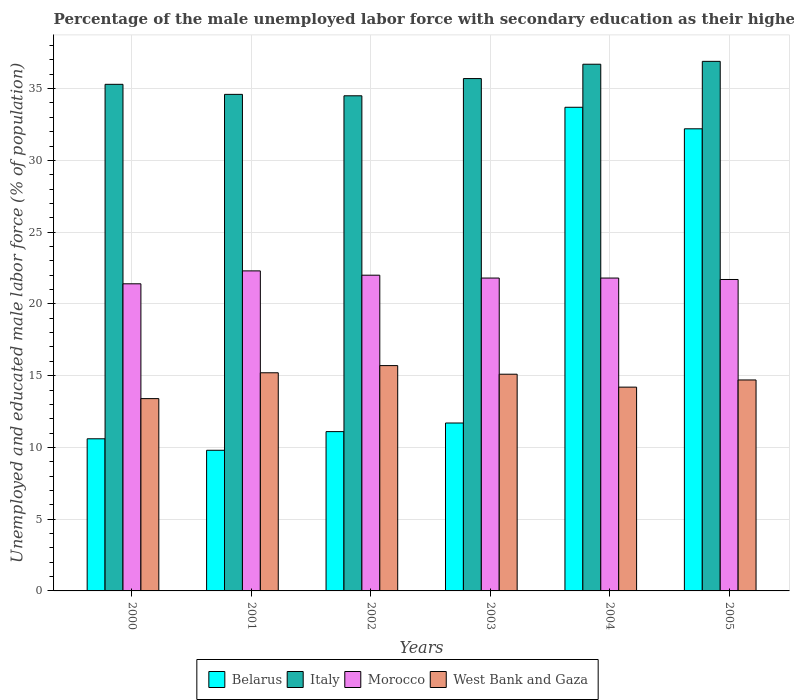How many groups of bars are there?
Offer a very short reply. 6. Are the number of bars on each tick of the X-axis equal?
Provide a short and direct response. Yes. What is the label of the 4th group of bars from the left?
Keep it short and to the point. 2003. What is the percentage of the unemployed male labor force with secondary education in West Bank and Gaza in 2001?
Offer a terse response. 15.2. Across all years, what is the maximum percentage of the unemployed male labor force with secondary education in West Bank and Gaza?
Make the answer very short. 15.7. Across all years, what is the minimum percentage of the unemployed male labor force with secondary education in Belarus?
Keep it short and to the point. 9.8. In which year was the percentage of the unemployed male labor force with secondary education in West Bank and Gaza maximum?
Your answer should be compact. 2002. In which year was the percentage of the unemployed male labor force with secondary education in Morocco minimum?
Your response must be concise. 2000. What is the total percentage of the unemployed male labor force with secondary education in Italy in the graph?
Your answer should be very brief. 213.7. What is the difference between the percentage of the unemployed male labor force with secondary education in West Bank and Gaza in 2001 and that in 2004?
Provide a succinct answer. 1. What is the difference between the percentage of the unemployed male labor force with secondary education in Morocco in 2003 and the percentage of the unemployed male labor force with secondary education in Belarus in 2002?
Offer a very short reply. 10.7. What is the average percentage of the unemployed male labor force with secondary education in Morocco per year?
Offer a terse response. 21.83. In the year 2001, what is the difference between the percentage of the unemployed male labor force with secondary education in West Bank and Gaza and percentage of the unemployed male labor force with secondary education in Italy?
Your response must be concise. -19.4. In how many years, is the percentage of the unemployed male labor force with secondary education in Morocco greater than 19 %?
Offer a terse response. 6. What is the ratio of the percentage of the unemployed male labor force with secondary education in Belarus in 2002 to that in 2003?
Make the answer very short. 0.95. Is the percentage of the unemployed male labor force with secondary education in Morocco in 2000 less than that in 2005?
Keep it short and to the point. Yes. Is the difference between the percentage of the unemployed male labor force with secondary education in West Bank and Gaza in 2001 and 2004 greater than the difference between the percentage of the unemployed male labor force with secondary education in Italy in 2001 and 2004?
Your answer should be very brief. Yes. What is the difference between the highest and the second highest percentage of the unemployed male labor force with secondary education in West Bank and Gaza?
Provide a succinct answer. 0.5. What is the difference between the highest and the lowest percentage of the unemployed male labor force with secondary education in West Bank and Gaza?
Your answer should be compact. 2.3. In how many years, is the percentage of the unemployed male labor force with secondary education in Morocco greater than the average percentage of the unemployed male labor force with secondary education in Morocco taken over all years?
Your answer should be very brief. 2. Is the sum of the percentage of the unemployed male labor force with secondary education in West Bank and Gaza in 2003 and 2004 greater than the maximum percentage of the unemployed male labor force with secondary education in Morocco across all years?
Keep it short and to the point. Yes. What does the 3rd bar from the left in 2000 represents?
Keep it short and to the point. Morocco. What does the 4th bar from the right in 2005 represents?
Offer a terse response. Belarus. Is it the case that in every year, the sum of the percentage of the unemployed male labor force with secondary education in Morocco and percentage of the unemployed male labor force with secondary education in Belarus is greater than the percentage of the unemployed male labor force with secondary education in Italy?
Provide a succinct answer. No. Are all the bars in the graph horizontal?
Ensure brevity in your answer.  No. What is the difference between two consecutive major ticks on the Y-axis?
Your answer should be very brief. 5. Does the graph contain any zero values?
Give a very brief answer. No. How many legend labels are there?
Provide a short and direct response. 4. What is the title of the graph?
Keep it short and to the point. Percentage of the male unemployed labor force with secondary education as their highest grade. Does "Cambodia" appear as one of the legend labels in the graph?
Give a very brief answer. No. What is the label or title of the Y-axis?
Provide a succinct answer. Unemployed and educated male labor force (% of population). What is the Unemployed and educated male labor force (% of population) of Belarus in 2000?
Provide a succinct answer. 10.6. What is the Unemployed and educated male labor force (% of population) of Italy in 2000?
Offer a very short reply. 35.3. What is the Unemployed and educated male labor force (% of population) of Morocco in 2000?
Ensure brevity in your answer.  21.4. What is the Unemployed and educated male labor force (% of population) in West Bank and Gaza in 2000?
Give a very brief answer. 13.4. What is the Unemployed and educated male labor force (% of population) of Belarus in 2001?
Your answer should be very brief. 9.8. What is the Unemployed and educated male labor force (% of population) in Italy in 2001?
Provide a short and direct response. 34.6. What is the Unemployed and educated male labor force (% of population) of Morocco in 2001?
Your answer should be very brief. 22.3. What is the Unemployed and educated male labor force (% of population) of West Bank and Gaza in 2001?
Your response must be concise. 15.2. What is the Unemployed and educated male labor force (% of population) of Belarus in 2002?
Make the answer very short. 11.1. What is the Unemployed and educated male labor force (% of population) in Italy in 2002?
Make the answer very short. 34.5. What is the Unemployed and educated male labor force (% of population) in West Bank and Gaza in 2002?
Provide a short and direct response. 15.7. What is the Unemployed and educated male labor force (% of population) in Belarus in 2003?
Provide a succinct answer. 11.7. What is the Unemployed and educated male labor force (% of population) of Italy in 2003?
Make the answer very short. 35.7. What is the Unemployed and educated male labor force (% of population) of Morocco in 2003?
Provide a succinct answer. 21.8. What is the Unemployed and educated male labor force (% of population) in West Bank and Gaza in 2003?
Ensure brevity in your answer.  15.1. What is the Unemployed and educated male labor force (% of population) in Belarus in 2004?
Offer a very short reply. 33.7. What is the Unemployed and educated male labor force (% of population) in Italy in 2004?
Offer a very short reply. 36.7. What is the Unemployed and educated male labor force (% of population) of Morocco in 2004?
Offer a terse response. 21.8. What is the Unemployed and educated male labor force (% of population) in West Bank and Gaza in 2004?
Your answer should be compact. 14.2. What is the Unemployed and educated male labor force (% of population) in Belarus in 2005?
Keep it short and to the point. 32.2. What is the Unemployed and educated male labor force (% of population) of Italy in 2005?
Provide a short and direct response. 36.9. What is the Unemployed and educated male labor force (% of population) of Morocco in 2005?
Offer a terse response. 21.7. What is the Unemployed and educated male labor force (% of population) in West Bank and Gaza in 2005?
Offer a very short reply. 14.7. Across all years, what is the maximum Unemployed and educated male labor force (% of population) of Belarus?
Provide a short and direct response. 33.7. Across all years, what is the maximum Unemployed and educated male labor force (% of population) in Italy?
Provide a succinct answer. 36.9. Across all years, what is the maximum Unemployed and educated male labor force (% of population) in Morocco?
Keep it short and to the point. 22.3. Across all years, what is the maximum Unemployed and educated male labor force (% of population) of West Bank and Gaza?
Your response must be concise. 15.7. Across all years, what is the minimum Unemployed and educated male labor force (% of population) of Belarus?
Offer a very short reply. 9.8. Across all years, what is the minimum Unemployed and educated male labor force (% of population) in Italy?
Give a very brief answer. 34.5. Across all years, what is the minimum Unemployed and educated male labor force (% of population) of Morocco?
Provide a short and direct response. 21.4. Across all years, what is the minimum Unemployed and educated male labor force (% of population) of West Bank and Gaza?
Provide a short and direct response. 13.4. What is the total Unemployed and educated male labor force (% of population) of Belarus in the graph?
Your answer should be very brief. 109.1. What is the total Unemployed and educated male labor force (% of population) in Italy in the graph?
Your answer should be compact. 213.7. What is the total Unemployed and educated male labor force (% of population) in Morocco in the graph?
Offer a terse response. 131. What is the total Unemployed and educated male labor force (% of population) in West Bank and Gaza in the graph?
Make the answer very short. 88.3. What is the difference between the Unemployed and educated male labor force (% of population) of Morocco in 2000 and that in 2001?
Ensure brevity in your answer.  -0.9. What is the difference between the Unemployed and educated male labor force (% of population) in West Bank and Gaza in 2000 and that in 2002?
Offer a terse response. -2.3. What is the difference between the Unemployed and educated male labor force (% of population) in West Bank and Gaza in 2000 and that in 2003?
Keep it short and to the point. -1.7. What is the difference between the Unemployed and educated male labor force (% of population) of Belarus in 2000 and that in 2004?
Offer a terse response. -23.1. What is the difference between the Unemployed and educated male labor force (% of population) in Morocco in 2000 and that in 2004?
Provide a short and direct response. -0.4. What is the difference between the Unemployed and educated male labor force (% of population) of Belarus in 2000 and that in 2005?
Offer a terse response. -21.6. What is the difference between the Unemployed and educated male labor force (% of population) in Italy in 2000 and that in 2005?
Give a very brief answer. -1.6. What is the difference between the Unemployed and educated male labor force (% of population) in Italy in 2001 and that in 2002?
Your answer should be compact. 0.1. What is the difference between the Unemployed and educated male labor force (% of population) in Morocco in 2001 and that in 2002?
Your answer should be compact. 0.3. What is the difference between the Unemployed and educated male labor force (% of population) in Belarus in 2001 and that in 2003?
Your answer should be compact. -1.9. What is the difference between the Unemployed and educated male labor force (% of population) of Morocco in 2001 and that in 2003?
Your answer should be very brief. 0.5. What is the difference between the Unemployed and educated male labor force (% of population) in West Bank and Gaza in 2001 and that in 2003?
Offer a terse response. 0.1. What is the difference between the Unemployed and educated male labor force (% of population) in Belarus in 2001 and that in 2004?
Your answer should be very brief. -23.9. What is the difference between the Unemployed and educated male labor force (% of population) in Italy in 2001 and that in 2004?
Your response must be concise. -2.1. What is the difference between the Unemployed and educated male labor force (% of population) in Morocco in 2001 and that in 2004?
Give a very brief answer. 0.5. What is the difference between the Unemployed and educated male labor force (% of population) of West Bank and Gaza in 2001 and that in 2004?
Offer a very short reply. 1. What is the difference between the Unemployed and educated male labor force (% of population) in Belarus in 2001 and that in 2005?
Your response must be concise. -22.4. What is the difference between the Unemployed and educated male labor force (% of population) of Italy in 2001 and that in 2005?
Give a very brief answer. -2.3. What is the difference between the Unemployed and educated male labor force (% of population) of Morocco in 2001 and that in 2005?
Keep it short and to the point. 0.6. What is the difference between the Unemployed and educated male labor force (% of population) of West Bank and Gaza in 2001 and that in 2005?
Keep it short and to the point. 0.5. What is the difference between the Unemployed and educated male labor force (% of population) in Morocco in 2002 and that in 2003?
Ensure brevity in your answer.  0.2. What is the difference between the Unemployed and educated male labor force (% of population) of Belarus in 2002 and that in 2004?
Provide a short and direct response. -22.6. What is the difference between the Unemployed and educated male labor force (% of population) in Italy in 2002 and that in 2004?
Provide a short and direct response. -2.2. What is the difference between the Unemployed and educated male labor force (% of population) of Morocco in 2002 and that in 2004?
Keep it short and to the point. 0.2. What is the difference between the Unemployed and educated male labor force (% of population) of West Bank and Gaza in 2002 and that in 2004?
Provide a succinct answer. 1.5. What is the difference between the Unemployed and educated male labor force (% of population) of Belarus in 2002 and that in 2005?
Offer a very short reply. -21.1. What is the difference between the Unemployed and educated male labor force (% of population) in Italy in 2002 and that in 2005?
Your answer should be very brief. -2.4. What is the difference between the Unemployed and educated male labor force (% of population) of Morocco in 2002 and that in 2005?
Make the answer very short. 0.3. What is the difference between the Unemployed and educated male labor force (% of population) of Belarus in 2003 and that in 2004?
Your response must be concise. -22. What is the difference between the Unemployed and educated male labor force (% of population) of Italy in 2003 and that in 2004?
Make the answer very short. -1. What is the difference between the Unemployed and educated male labor force (% of population) of Belarus in 2003 and that in 2005?
Give a very brief answer. -20.5. What is the difference between the Unemployed and educated male labor force (% of population) in West Bank and Gaza in 2003 and that in 2005?
Make the answer very short. 0.4. What is the difference between the Unemployed and educated male labor force (% of population) of Belarus in 2004 and that in 2005?
Your response must be concise. 1.5. What is the difference between the Unemployed and educated male labor force (% of population) in Italy in 2004 and that in 2005?
Give a very brief answer. -0.2. What is the difference between the Unemployed and educated male labor force (% of population) of West Bank and Gaza in 2004 and that in 2005?
Your answer should be compact. -0.5. What is the difference between the Unemployed and educated male labor force (% of population) of Belarus in 2000 and the Unemployed and educated male labor force (% of population) of West Bank and Gaza in 2001?
Offer a terse response. -4.6. What is the difference between the Unemployed and educated male labor force (% of population) of Italy in 2000 and the Unemployed and educated male labor force (% of population) of Morocco in 2001?
Give a very brief answer. 13. What is the difference between the Unemployed and educated male labor force (% of population) of Italy in 2000 and the Unemployed and educated male labor force (% of population) of West Bank and Gaza in 2001?
Your answer should be compact. 20.1. What is the difference between the Unemployed and educated male labor force (% of population) in Belarus in 2000 and the Unemployed and educated male labor force (% of population) in Italy in 2002?
Your answer should be compact. -23.9. What is the difference between the Unemployed and educated male labor force (% of population) in Belarus in 2000 and the Unemployed and educated male labor force (% of population) in Morocco in 2002?
Your response must be concise. -11.4. What is the difference between the Unemployed and educated male labor force (% of population) of Belarus in 2000 and the Unemployed and educated male labor force (% of population) of West Bank and Gaza in 2002?
Ensure brevity in your answer.  -5.1. What is the difference between the Unemployed and educated male labor force (% of population) in Italy in 2000 and the Unemployed and educated male labor force (% of population) in Morocco in 2002?
Provide a succinct answer. 13.3. What is the difference between the Unemployed and educated male labor force (% of population) of Italy in 2000 and the Unemployed and educated male labor force (% of population) of West Bank and Gaza in 2002?
Ensure brevity in your answer.  19.6. What is the difference between the Unemployed and educated male labor force (% of population) of Belarus in 2000 and the Unemployed and educated male labor force (% of population) of Italy in 2003?
Offer a terse response. -25.1. What is the difference between the Unemployed and educated male labor force (% of population) of Belarus in 2000 and the Unemployed and educated male labor force (% of population) of Morocco in 2003?
Keep it short and to the point. -11.2. What is the difference between the Unemployed and educated male labor force (% of population) in Italy in 2000 and the Unemployed and educated male labor force (% of population) in West Bank and Gaza in 2003?
Give a very brief answer. 20.2. What is the difference between the Unemployed and educated male labor force (% of population) in Belarus in 2000 and the Unemployed and educated male labor force (% of population) in Italy in 2004?
Your response must be concise. -26.1. What is the difference between the Unemployed and educated male labor force (% of population) of Belarus in 2000 and the Unemployed and educated male labor force (% of population) of Morocco in 2004?
Offer a terse response. -11.2. What is the difference between the Unemployed and educated male labor force (% of population) in Italy in 2000 and the Unemployed and educated male labor force (% of population) in Morocco in 2004?
Your response must be concise. 13.5. What is the difference between the Unemployed and educated male labor force (% of population) of Italy in 2000 and the Unemployed and educated male labor force (% of population) of West Bank and Gaza in 2004?
Provide a succinct answer. 21.1. What is the difference between the Unemployed and educated male labor force (% of population) of Belarus in 2000 and the Unemployed and educated male labor force (% of population) of Italy in 2005?
Your answer should be very brief. -26.3. What is the difference between the Unemployed and educated male labor force (% of population) in Belarus in 2000 and the Unemployed and educated male labor force (% of population) in West Bank and Gaza in 2005?
Ensure brevity in your answer.  -4.1. What is the difference between the Unemployed and educated male labor force (% of population) of Italy in 2000 and the Unemployed and educated male labor force (% of population) of West Bank and Gaza in 2005?
Provide a short and direct response. 20.6. What is the difference between the Unemployed and educated male labor force (% of population) in Morocco in 2000 and the Unemployed and educated male labor force (% of population) in West Bank and Gaza in 2005?
Keep it short and to the point. 6.7. What is the difference between the Unemployed and educated male labor force (% of population) in Belarus in 2001 and the Unemployed and educated male labor force (% of population) in Italy in 2002?
Offer a terse response. -24.7. What is the difference between the Unemployed and educated male labor force (% of population) in Belarus in 2001 and the Unemployed and educated male labor force (% of population) in Morocco in 2002?
Make the answer very short. -12.2. What is the difference between the Unemployed and educated male labor force (% of population) in Belarus in 2001 and the Unemployed and educated male labor force (% of population) in West Bank and Gaza in 2002?
Your response must be concise. -5.9. What is the difference between the Unemployed and educated male labor force (% of population) in Italy in 2001 and the Unemployed and educated male labor force (% of population) in Morocco in 2002?
Your response must be concise. 12.6. What is the difference between the Unemployed and educated male labor force (% of population) of Belarus in 2001 and the Unemployed and educated male labor force (% of population) of Italy in 2003?
Offer a terse response. -25.9. What is the difference between the Unemployed and educated male labor force (% of population) of Belarus in 2001 and the Unemployed and educated male labor force (% of population) of Morocco in 2003?
Your answer should be compact. -12. What is the difference between the Unemployed and educated male labor force (% of population) of Belarus in 2001 and the Unemployed and educated male labor force (% of population) of West Bank and Gaza in 2003?
Keep it short and to the point. -5.3. What is the difference between the Unemployed and educated male labor force (% of population) of Italy in 2001 and the Unemployed and educated male labor force (% of population) of West Bank and Gaza in 2003?
Keep it short and to the point. 19.5. What is the difference between the Unemployed and educated male labor force (% of population) of Belarus in 2001 and the Unemployed and educated male labor force (% of population) of Italy in 2004?
Your response must be concise. -26.9. What is the difference between the Unemployed and educated male labor force (% of population) of Belarus in 2001 and the Unemployed and educated male labor force (% of population) of Morocco in 2004?
Ensure brevity in your answer.  -12. What is the difference between the Unemployed and educated male labor force (% of population) of Italy in 2001 and the Unemployed and educated male labor force (% of population) of West Bank and Gaza in 2004?
Provide a short and direct response. 20.4. What is the difference between the Unemployed and educated male labor force (% of population) of Morocco in 2001 and the Unemployed and educated male labor force (% of population) of West Bank and Gaza in 2004?
Your answer should be compact. 8.1. What is the difference between the Unemployed and educated male labor force (% of population) of Belarus in 2001 and the Unemployed and educated male labor force (% of population) of Italy in 2005?
Provide a short and direct response. -27.1. What is the difference between the Unemployed and educated male labor force (% of population) in Belarus in 2001 and the Unemployed and educated male labor force (% of population) in Morocco in 2005?
Your response must be concise. -11.9. What is the difference between the Unemployed and educated male labor force (% of population) in Belarus in 2002 and the Unemployed and educated male labor force (% of population) in Italy in 2003?
Keep it short and to the point. -24.6. What is the difference between the Unemployed and educated male labor force (% of population) in Belarus in 2002 and the Unemployed and educated male labor force (% of population) in Morocco in 2003?
Ensure brevity in your answer.  -10.7. What is the difference between the Unemployed and educated male labor force (% of population) of Italy in 2002 and the Unemployed and educated male labor force (% of population) of Morocco in 2003?
Offer a terse response. 12.7. What is the difference between the Unemployed and educated male labor force (% of population) in Belarus in 2002 and the Unemployed and educated male labor force (% of population) in Italy in 2004?
Provide a short and direct response. -25.6. What is the difference between the Unemployed and educated male labor force (% of population) of Belarus in 2002 and the Unemployed and educated male labor force (% of population) of West Bank and Gaza in 2004?
Make the answer very short. -3.1. What is the difference between the Unemployed and educated male labor force (% of population) of Italy in 2002 and the Unemployed and educated male labor force (% of population) of Morocco in 2004?
Your response must be concise. 12.7. What is the difference between the Unemployed and educated male labor force (% of population) of Italy in 2002 and the Unemployed and educated male labor force (% of population) of West Bank and Gaza in 2004?
Offer a very short reply. 20.3. What is the difference between the Unemployed and educated male labor force (% of population) in Belarus in 2002 and the Unemployed and educated male labor force (% of population) in Italy in 2005?
Make the answer very short. -25.8. What is the difference between the Unemployed and educated male labor force (% of population) of Belarus in 2002 and the Unemployed and educated male labor force (% of population) of Morocco in 2005?
Keep it short and to the point. -10.6. What is the difference between the Unemployed and educated male labor force (% of population) in Belarus in 2002 and the Unemployed and educated male labor force (% of population) in West Bank and Gaza in 2005?
Offer a very short reply. -3.6. What is the difference between the Unemployed and educated male labor force (% of population) of Italy in 2002 and the Unemployed and educated male labor force (% of population) of West Bank and Gaza in 2005?
Offer a terse response. 19.8. What is the difference between the Unemployed and educated male labor force (% of population) of Morocco in 2002 and the Unemployed and educated male labor force (% of population) of West Bank and Gaza in 2005?
Ensure brevity in your answer.  7.3. What is the difference between the Unemployed and educated male labor force (% of population) of Belarus in 2003 and the Unemployed and educated male labor force (% of population) of West Bank and Gaza in 2004?
Give a very brief answer. -2.5. What is the difference between the Unemployed and educated male labor force (% of population) in Italy in 2003 and the Unemployed and educated male labor force (% of population) in West Bank and Gaza in 2004?
Your answer should be compact. 21.5. What is the difference between the Unemployed and educated male labor force (% of population) in Belarus in 2003 and the Unemployed and educated male labor force (% of population) in Italy in 2005?
Your answer should be very brief. -25.2. What is the difference between the Unemployed and educated male labor force (% of population) of Italy in 2003 and the Unemployed and educated male labor force (% of population) of Morocco in 2005?
Provide a succinct answer. 14. What is the difference between the Unemployed and educated male labor force (% of population) of Morocco in 2003 and the Unemployed and educated male labor force (% of population) of West Bank and Gaza in 2005?
Make the answer very short. 7.1. What is the difference between the Unemployed and educated male labor force (% of population) of Belarus in 2004 and the Unemployed and educated male labor force (% of population) of Italy in 2005?
Give a very brief answer. -3.2. What is the difference between the Unemployed and educated male labor force (% of population) in Belarus in 2004 and the Unemployed and educated male labor force (% of population) in West Bank and Gaza in 2005?
Keep it short and to the point. 19. What is the difference between the Unemployed and educated male labor force (% of population) in Italy in 2004 and the Unemployed and educated male labor force (% of population) in Morocco in 2005?
Make the answer very short. 15. What is the difference between the Unemployed and educated male labor force (% of population) of Morocco in 2004 and the Unemployed and educated male labor force (% of population) of West Bank and Gaza in 2005?
Offer a terse response. 7.1. What is the average Unemployed and educated male labor force (% of population) of Belarus per year?
Ensure brevity in your answer.  18.18. What is the average Unemployed and educated male labor force (% of population) in Italy per year?
Provide a short and direct response. 35.62. What is the average Unemployed and educated male labor force (% of population) of Morocco per year?
Ensure brevity in your answer.  21.83. What is the average Unemployed and educated male labor force (% of population) in West Bank and Gaza per year?
Make the answer very short. 14.72. In the year 2000, what is the difference between the Unemployed and educated male labor force (% of population) of Belarus and Unemployed and educated male labor force (% of population) of Italy?
Make the answer very short. -24.7. In the year 2000, what is the difference between the Unemployed and educated male labor force (% of population) in Belarus and Unemployed and educated male labor force (% of population) in Morocco?
Provide a succinct answer. -10.8. In the year 2000, what is the difference between the Unemployed and educated male labor force (% of population) in Italy and Unemployed and educated male labor force (% of population) in Morocco?
Keep it short and to the point. 13.9. In the year 2000, what is the difference between the Unemployed and educated male labor force (% of population) of Italy and Unemployed and educated male labor force (% of population) of West Bank and Gaza?
Ensure brevity in your answer.  21.9. In the year 2000, what is the difference between the Unemployed and educated male labor force (% of population) of Morocco and Unemployed and educated male labor force (% of population) of West Bank and Gaza?
Offer a very short reply. 8. In the year 2001, what is the difference between the Unemployed and educated male labor force (% of population) of Belarus and Unemployed and educated male labor force (% of population) of Italy?
Give a very brief answer. -24.8. In the year 2001, what is the difference between the Unemployed and educated male labor force (% of population) in Belarus and Unemployed and educated male labor force (% of population) in Morocco?
Give a very brief answer. -12.5. In the year 2001, what is the difference between the Unemployed and educated male labor force (% of population) in Belarus and Unemployed and educated male labor force (% of population) in West Bank and Gaza?
Your answer should be very brief. -5.4. In the year 2001, what is the difference between the Unemployed and educated male labor force (% of population) in Morocco and Unemployed and educated male labor force (% of population) in West Bank and Gaza?
Offer a very short reply. 7.1. In the year 2002, what is the difference between the Unemployed and educated male labor force (% of population) in Belarus and Unemployed and educated male labor force (% of population) in Italy?
Ensure brevity in your answer.  -23.4. In the year 2002, what is the difference between the Unemployed and educated male labor force (% of population) of Belarus and Unemployed and educated male labor force (% of population) of Morocco?
Offer a terse response. -10.9. In the year 2002, what is the difference between the Unemployed and educated male labor force (% of population) in Belarus and Unemployed and educated male labor force (% of population) in West Bank and Gaza?
Provide a short and direct response. -4.6. In the year 2002, what is the difference between the Unemployed and educated male labor force (% of population) in Italy and Unemployed and educated male labor force (% of population) in West Bank and Gaza?
Your answer should be compact. 18.8. In the year 2003, what is the difference between the Unemployed and educated male labor force (% of population) of Belarus and Unemployed and educated male labor force (% of population) of Italy?
Make the answer very short. -24. In the year 2003, what is the difference between the Unemployed and educated male labor force (% of population) in Belarus and Unemployed and educated male labor force (% of population) in West Bank and Gaza?
Provide a succinct answer. -3.4. In the year 2003, what is the difference between the Unemployed and educated male labor force (% of population) in Italy and Unemployed and educated male labor force (% of population) in Morocco?
Ensure brevity in your answer.  13.9. In the year 2003, what is the difference between the Unemployed and educated male labor force (% of population) of Italy and Unemployed and educated male labor force (% of population) of West Bank and Gaza?
Give a very brief answer. 20.6. In the year 2003, what is the difference between the Unemployed and educated male labor force (% of population) of Morocco and Unemployed and educated male labor force (% of population) of West Bank and Gaza?
Your answer should be very brief. 6.7. In the year 2004, what is the difference between the Unemployed and educated male labor force (% of population) in Belarus and Unemployed and educated male labor force (% of population) in West Bank and Gaza?
Give a very brief answer. 19.5. In the year 2004, what is the difference between the Unemployed and educated male labor force (% of population) in Italy and Unemployed and educated male labor force (% of population) in Morocco?
Provide a short and direct response. 14.9. In the year 2004, what is the difference between the Unemployed and educated male labor force (% of population) of Morocco and Unemployed and educated male labor force (% of population) of West Bank and Gaza?
Give a very brief answer. 7.6. In the year 2005, what is the difference between the Unemployed and educated male labor force (% of population) in Belarus and Unemployed and educated male labor force (% of population) in Italy?
Your answer should be compact. -4.7. In the year 2005, what is the difference between the Unemployed and educated male labor force (% of population) of Belarus and Unemployed and educated male labor force (% of population) of Morocco?
Provide a short and direct response. 10.5. In the year 2005, what is the difference between the Unemployed and educated male labor force (% of population) in Italy and Unemployed and educated male labor force (% of population) in Morocco?
Ensure brevity in your answer.  15.2. In the year 2005, what is the difference between the Unemployed and educated male labor force (% of population) of Italy and Unemployed and educated male labor force (% of population) of West Bank and Gaza?
Provide a succinct answer. 22.2. In the year 2005, what is the difference between the Unemployed and educated male labor force (% of population) of Morocco and Unemployed and educated male labor force (% of population) of West Bank and Gaza?
Make the answer very short. 7. What is the ratio of the Unemployed and educated male labor force (% of population) in Belarus in 2000 to that in 2001?
Ensure brevity in your answer.  1.08. What is the ratio of the Unemployed and educated male labor force (% of population) in Italy in 2000 to that in 2001?
Your response must be concise. 1.02. What is the ratio of the Unemployed and educated male labor force (% of population) in Morocco in 2000 to that in 2001?
Provide a short and direct response. 0.96. What is the ratio of the Unemployed and educated male labor force (% of population) of West Bank and Gaza in 2000 to that in 2001?
Your answer should be compact. 0.88. What is the ratio of the Unemployed and educated male labor force (% of population) in Belarus in 2000 to that in 2002?
Give a very brief answer. 0.95. What is the ratio of the Unemployed and educated male labor force (% of population) of Italy in 2000 to that in 2002?
Keep it short and to the point. 1.02. What is the ratio of the Unemployed and educated male labor force (% of population) of Morocco in 2000 to that in 2002?
Your response must be concise. 0.97. What is the ratio of the Unemployed and educated male labor force (% of population) of West Bank and Gaza in 2000 to that in 2002?
Ensure brevity in your answer.  0.85. What is the ratio of the Unemployed and educated male labor force (% of population) in Belarus in 2000 to that in 2003?
Offer a very short reply. 0.91. What is the ratio of the Unemployed and educated male labor force (% of population) in Morocco in 2000 to that in 2003?
Offer a very short reply. 0.98. What is the ratio of the Unemployed and educated male labor force (% of population) in West Bank and Gaza in 2000 to that in 2003?
Give a very brief answer. 0.89. What is the ratio of the Unemployed and educated male labor force (% of population) in Belarus in 2000 to that in 2004?
Keep it short and to the point. 0.31. What is the ratio of the Unemployed and educated male labor force (% of population) of Italy in 2000 to that in 2004?
Make the answer very short. 0.96. What is the ratio of the Unemployed and educated male labor force (% of population) in Morocco in 2000 to that in 2004?
Provide a short and direct response. 0.98. What is the ratio of the Unemployed and educated male labor force (% of population) of West Bank and Gaza in 2000 to that in 2004?
Offer a very short reply. 0.94. What is the ratio of the Unemployed and educated male labor force (% of population) of Belarus in 2000 to that in 2005?
Your response must be concise. 0.33. What is the ratio of the Unemployed and educated male labor force (% of population) in Italy in 2000 to that in 2005?
Keep it short and to the point. 0.96. What is the ratio of the Unemployed and educated male labor force (% of population) in Morocco in 2000 to that in 2005?
Make the answer very short. 0.99. What is the ratio of the Unemployed and educated male labor force (% of population) in West Bank and Gaza in 2000 to that in 2005?
Your answer should be very brief. 0.91. What is the ratio of the Unemployed and educated male labor force (% of population) of Belarus in 2001 to that in 2002?
Provide a succinct answer. 0.88. What is the ratio of the Unemployed and educated male labor force (% of population) in Italy in 2001 to that in 2002?
Your answer should be very brief. 1. What is the ratio of the Unemployed and educated male labor force (% of population) in Morocco in 2001 to that in 2002?
Your answer should be compact. 1.01. What is the ratio of the Unemployed and educated male labor force (% of population) in West Bank and Gaza in 2001 to that in 2002?
Offer a very short reply. 0.97. What is the ratio of the Unemployed and educated male labor force (% of population) in Belarus in 2001 to that in 2003?
Make the answer very short. 0.84. What is the ratio of the Unemployed and educated male labor force (% of population) in Italy in 2001 to that in 2003?
Give a very brief answer. 0.97. What is the ratio of the Unemployed and educated male labor force (% of population) in Morocco in 2001 to that in 2003?
Make the answer very short. 1.02. What is the ratio of the Unemployed and educated male labor force (% of population) in West Bank and Gaza in 2001 to that in 2003?
Your response must be concise. 1.01. What is the ratio of the Unemployed and educated male labor force (% of population) of Belarus in 2001 to that in 2004?
Your answer should be very brief. 0.29. What is the ratio of the Unemployed and educated male labor force (% of population) in Italy in 2001 to that in 2004?
Your response must be concise. 0.94. What is the ratio of the Unemployed and educated male labor force (% of population) of Morocco in 2001 to that in 2004?
Keep it short and to the point. 1.02. What is the ratio of the Unemployed and educated male labor force (% of population) in West Bank and Gaza in 2001 to that in 2004?
Your answer should be compact. 1.07. What is the ratio of the Unemployed and educated male labor force (% of population) in Belarus in 2001 to that in 2005?
Make the answer very short. 0.3. What is the ratio of the Unemployed and educated male labor force (% of population) of Italy in 2001 to that in 2005?
Your response must be concise. 0.94. What is the ratio of the Unemployed and educated male labor force (% of population) in Morocco in 2001 to that in 2005?
Your answer should be compact. 1.03. What is the ratio of the Unemployed and educated male labor force (% of population) in West Bank and Gaza in 2001 to that in 2005?
Keep it short and to the point. 1.03. What is the ratio of the Unemployed and educated male labor force (% of population) in Belarus in 2002 to that in 2003?
Provide a succinct answer. 0.95. What is the ratio of the Unemployed and educated male labor force (% of population) in Italy in 2002 to that in 2003?
Provide a short and direct response. 0.97. What is the ratio of the Unemployed and educated male labor force (% of population) of Morocco in 2002 to that in 2003?
Provide a short and direct response. 1.01. What is the ratio of the Unemployed and educated male labor force (% of population) in West Bank and Gaza in 2002 to that in 2003?
Ensure brevity in your answer.  1.04. What is the ratio of the Unemployed and educated male labor force (% of population) of Belarus in 2002 to that in 2004?
Make the answer very short. 0.33. What is the ratio of the Unemployed and educated male labor force (% of population) in Italy in 2002 to that in 2004?
Keep it short and to the point. 0.94. What is the ratio of the Unemployed and educated male labor force (% of population) in Morocco in 2002 to that in 2004?
Give a very brief answer. 1.01. What is the ratio of the Unemployed and educated male labor force (% of population) of West Bank and Gaza in 2002 to that in 2004?
Provide a succinct answer. 1.11. What is the ratio of the Unemployed and educated male labor force (% of population) in Belarus in 2002 to that in 2005?
Offer a terse response. 0.34. What is the ratio of the Unemployed and educated male labor force (% of population) in Italy in 2002 to that in 2005?
Offer a very short reply. 0.94. What is the ratio of the Unemployed and educated male labor force (% of population) in Morocco in 2002 to that in 2005?
Your answer should be very brief. 1.01. What is the ratio of the Unemployed and educated male labor force (% of population) in West Bank and Gaza in 2002 to that in 2005?
Give a very brief answer. 1.07. What is the ratio of the Unemployed and educated male labor force (% of population) in Belarus in 2003 to that in 2004?
Offer a terse response. 0.35. What is the ratio of the Unemployed and educated male labor force (% of population) in Italy in 2003 to that in 2004?
Your response must be concise. 0.97. What is the ratio of the Unemployed and educated male labor force (% of population) of Morocco in 2003 to that in 2004?
Ensure brevity in your answer.  1. What is the ratio of the Unemployed and educated male labor force (% of population) of West Bank and Gaza in 2003 to that in 2004?
Provide a short and direct response. 1.06. What is the ratio of the Unemployed and educated male labor force (% of population) in Belarus in 2003 to that in 2005?
Offer a terse response. 0.36. What is the ratio of the Unemployed and educated male labor force (% of population) of Italy in 2003 to that in 2005?
Your answer should be very brief. 0.97. What is the ratio of the Unemployed and educated male labor force (% of population) of Morocco in 2003 to that in 2005?
Keep it short and to the point. 1. What is the ratio of the Unemployed and educated male labor force (% of population) in West Bank and Gaza in 2003 to that in 2005?
Give a very brief answer. 1.03. What is the ratio of the Unemployed and educated male labor force (% of population) of Belarus in 2004 to that in 2005?
Provide a short and direct response. 1.05. What is the ratio of the Unemployed and educated male labor force (% of population) in Morocco in 2004 to that in 2005?
Keep it short and to the point. 1. What is the difference between the highest and the second highest Unemployed and educated male labor force (% of population) in Morocco?
Provide a succinct answer. 0.3. What is the difference between the highest and the second highest Unemployed and educated male labor force (% of population) of West Bank and Gaza?
Provide a short and direct response. 0.5. What is the difference between the highest and the lowest Unemployed and educated male labor force (% of population) in Belarus?
Give a very brief answer. 23.9. What is the difference between the highest and the lowest Unemployed and educated male labor force (% of population) in Italy?
Offer a terse response. 2.4. What is the difference between the highest and the lowest Unemployed and educated male labor force (% of population) of Morocco?
Your answer should be very brief. 0.9. 